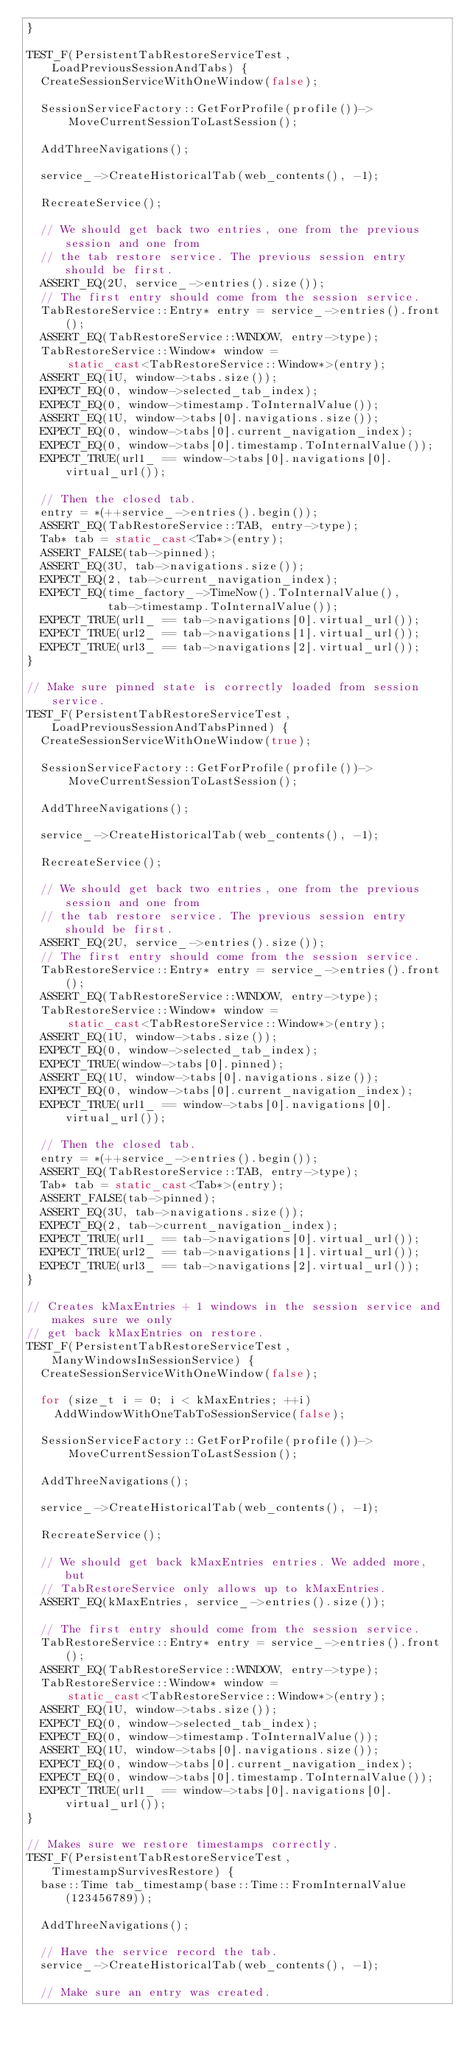Convert code to text. <code><loc_0><loc_0><loc_500><loc_500><_C++_>}

TEST_F(PersistentTabRestoreServiceTest, LoadPreviousSessionAndTabs) {
  CreateSessionServiceWithOneWindow(false);

  SessionServiceFactory::GetForProfile(profile())->
      MoveCurrentSessionToLastSession();

  AddThreeNavigations();

  service_->CreateHistoricalTab(web_contents(), -1);

  RecreateService();

  // We should get back two entries, one from the previous session and one from
  // the tab restore service. The previous session entry should be first.
  ASSERT_EQ(2U, service_->entries().size());
  // The first entry should come from the session service.
  TabRestoreService::Entry* entry = service_->entries().front();
  ASSERT_EQ(TabRestoreService::WINDOW, entry->type);
  TabRestoreService::Window* window =
      static_cast<TabRestoreService::Window*>(entry);
  ASSERT_EQ(1U, window->tabs.size());
  EXPECT_EQ(0, window->selected_tab_index);
  EXPECT_EQ(0, window->timestamp.ToInternalValue());
  ASSERT_EQ(1U, window->tabs[0].navigations.size());
  EXPECT_EQ(0, window->tabs[0].current_navigation_index);
  EXPECT_EQ(0, window->tabs[0].timestamp.ToInternalValue());
  EXPECT_TRUE(url1_ == window->tabs[0].navigations[0].virtual_url());

  // Then the closed tab.
  entry = *(++service_->entries().begin());
  ASSERT_EQ(TabRestoreService::TAB, entry->type);
  Tab* tab = static_cast<Tab*>(entry);
  ASSERT_FALSE(tab->pinned);
  ASSERT_EQ(3U, tab->navigations.size());
  EXPECT_EQ(2, tab->current_navigation_index);
  EXPECT_EQ(time_factory_->TimeNow().ToInternalValue(),
            tab->timestamp.ToInternalValue());
  EXPECT_TRUE(url1_ == tab->navigations[0].virtual_url());
  EXPECT_TRUE(url2_ == tab->navigations[1].virtual_url());
  EXPECT_TRUE(url3_ == tab->navigations[2].virtual_url());
}

// Make sure pinned state is correctly loaded from session service.
TEST_F(PersistentTabRestoreServiceTest, LoadPreviousSessionAndTabsPinned) {
  CreateSessionServiceWithOneWindow(true);

  SessionServiceFactory::GetForProfile(profile())->
      MoveCurrentSessionToLastSession();

  AddThreeNavigations();

  service_->CreateHistoricalTab(web_contents(), -1);

  RecreateService();

  // We should get back two entries, one from the previous session and one from
  // the tab restore service. The previous session entry should be first.
  ASSERT_EQ(2U, service_->entries().size());
  // The first entry should come from the session service.
  TabRestoreService::Entry* entry = service_->entries().front();
  ASSERT_EQ(TabRestoreService::WINDOW, entry->type);
  TabRestoreService::Window* window =
      static_cast<TabRestoreService::Window*>(entry);
  ASSERT_EQ(1U, window->tabs.size());
  EXPECT_EQ(0, window->selected_tab_index);
  EXPECT_TRUE(window->tabs[0].pinned);
  ASSERT_EQ(1U, window->tabs[0].navigations.size());
  EXPECT_EQ(0, window->tabs[0].current_navigation_index);
  EXPECT_TRUE(url1_ == window->tabs[0].navigations[0].virtual_url());

  // Then the closed tab.
  entry = *(++service_->entries().begin());
  ASSERT_EQ(TabRestoreService::TAB, entry->type);
  Tab* tab = static_cast<Tab*>(entry);
  ASSERT_FALSE(tab->pinned);
  ASSERT_EQ(3U, tab->navigations.size());
  EXPECT_EQ(2, tab->current_navigation_index);
  EXPECT_TRUE(url1_ == tab->navigations[0].virtual_url());
  EXPECT_TRUE(url2_ == tab->navigations[1].virtual_url());
  EXPECT_TRUE(url3_ == tab->navigations[2].virtual_url());
}

// Creates kMaxEntries + 1 windows in the session service and makes sure we only
// get back kMaxEntries on restore.
TEST_F(PersistentTabRestoreServiceTest, ManyWindowsInSessionService) {
  CreateSessionServiceWithOneWindow(false);

  for (size_t i = 0; i < kMaxEntries; ++i)
    AddWindowWithOneTabToSessionService(false);

  SessionServiceFactory::GetForProfile(profile())->
      MoveCurrentSessionToLastSession();

  AddThreeNavigations();

  service_->CreateHistoricalTab(web_contents(), -1);

  RecreateService();

  // We should get back kMaxEntries entries. We added more, but
  // TabRestoreService only allows up to kMaxEntries.
  ASSERT_EQ(kMaxEntries, service_->entries().size());

  // The first entry should come from the session service.
  TabRestoreService::Entry* entry = service_->entries().front();
  ASSERT_EQ(TabRestoreService::WINDOW, entry->type);
  TabRestoreService::Window* window =
      static_cast<TabRestoreService::Window*>(entry);
  ASSERT_EQ(1U, window->tabs.size());
  EXPECT_EQ(0, window->selected_tab_index);
  EXPECT_EQ(0, window->timestamp.ToInternalValue());
  ASSERT_EQ(1U, window->tabs[0].navigations.size());
  EXPECT_EQ(0, window->tabs[0].current_navigation_index);
  EXPECT_EQ(0, window->tabs[0].timestamp.ToInternalValue());
  EXPECT_TRUE(url1_ == window->tabs[0].navigations[0].virtual_url());
}

// Makes sure we restore timestamps correctly.
TEST_F(PersistentTabRestoreServiceTest, TimestampSurvivesRestore) {
  base::Time tab_timestamp(base::Time::FromInternalValue(123456789));

  AddThreeNavigations();

  // Have the service record the tab.
  service_->CreateHistoricalTab(web_contents(), -1);

  // Make sure an entry was created.</code> 